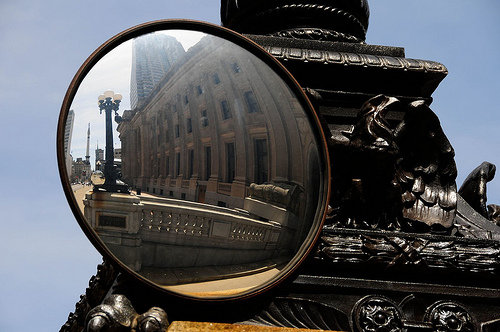<image>
Is there a lamp post behind the ornate roof? No. The lamp post is not behind the ornate roof. From this viewpoint, the lamp post appears to be positioned elsewhere in the scene. Is the building next to the statue? No. The building is not positioned next to the statue. They are located in different areas of the scene. 